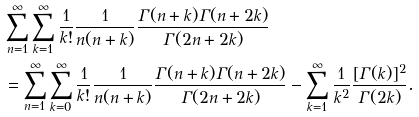<formula> <loc_0><loc_0><loc_500><loc_500>& \sum _ { n = 1 } ^ { \infty } \sum _ { k = 1 } ^ { \infty } \frac { 1 } { k ! } \frac { 1 } { n ( n + k ) } \frac { \Gamma ( n + k ) \Gamma ( n + 2 k ) } { \Gamma ( 2 n + 2 k ) } \\ & = \sum _ { n = 1 } ^ { \infty } \sum _ { k = 0 } ^ { \infty } \frac { 1 } { k ! } \frac { 1 } { n ( n + k ) } \frac { \Gamma ( n + k ) \Gamma ( n + 2 k ) } { \Gamma ( 2 n + 2 k ) } - \sum _ { k = 1 } ^ { \infty } \frac { 1 } { k ^ { 2 } } \frac { [ \Gamma ( k ) ] ^ { 2 } } { \Gamma ( 2 k ) } .</formula> 